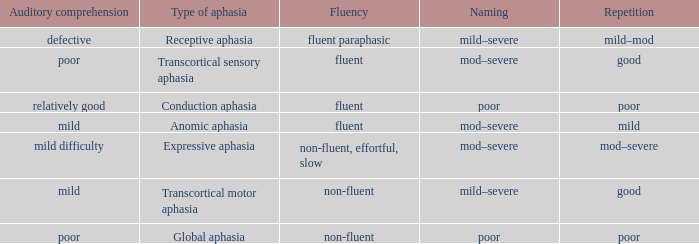Name the naming for fluent and poor comprehension Mod–severe. 